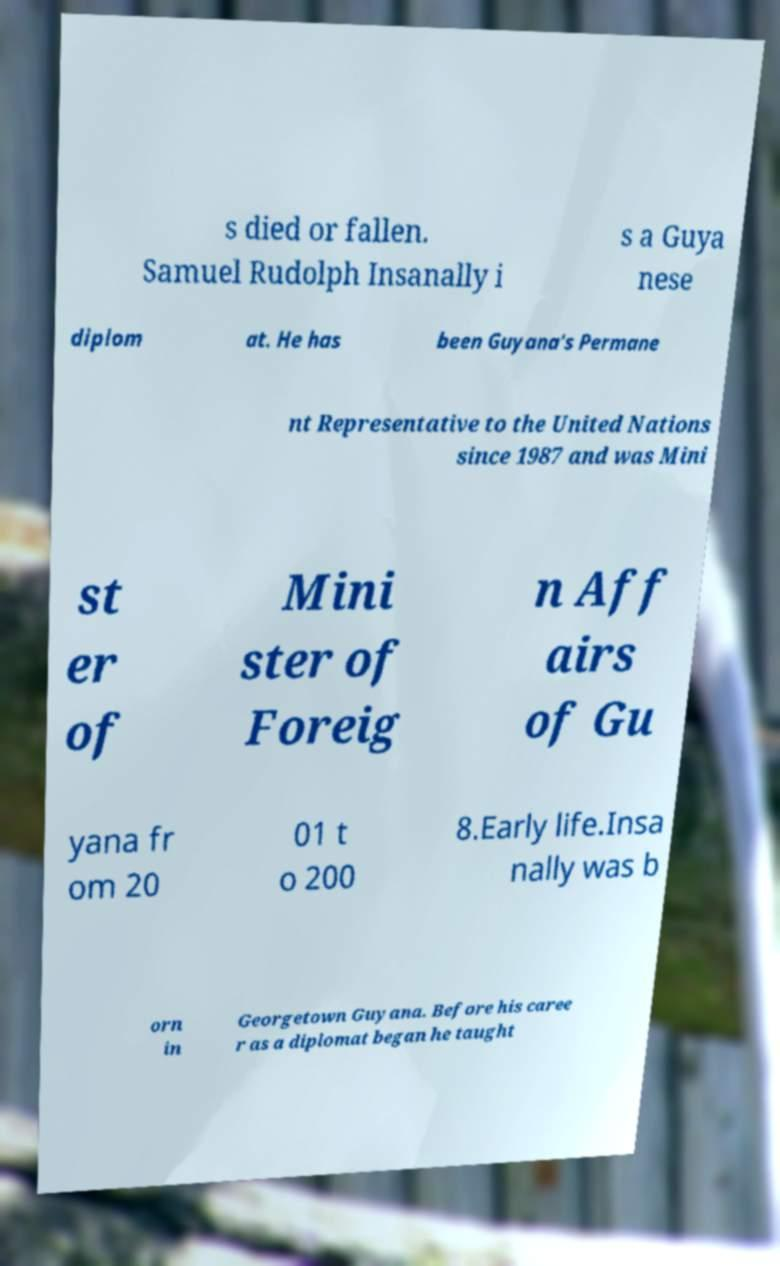Could you extract and type out the text from this image? s died or fallen. Samuel Rudolph Insanally i s a Guya nese diplom at. He has been Guyana's Permane nt Representative to the United Nations since 1987 and was Mini st er of Mini ster of Foreig n Aff airs of Gu yana fr om 20 01 t o 200 8.Early life.Insa nally was b orn in Georgetown Guyana. Before his caree r as a diplomat began he taught 